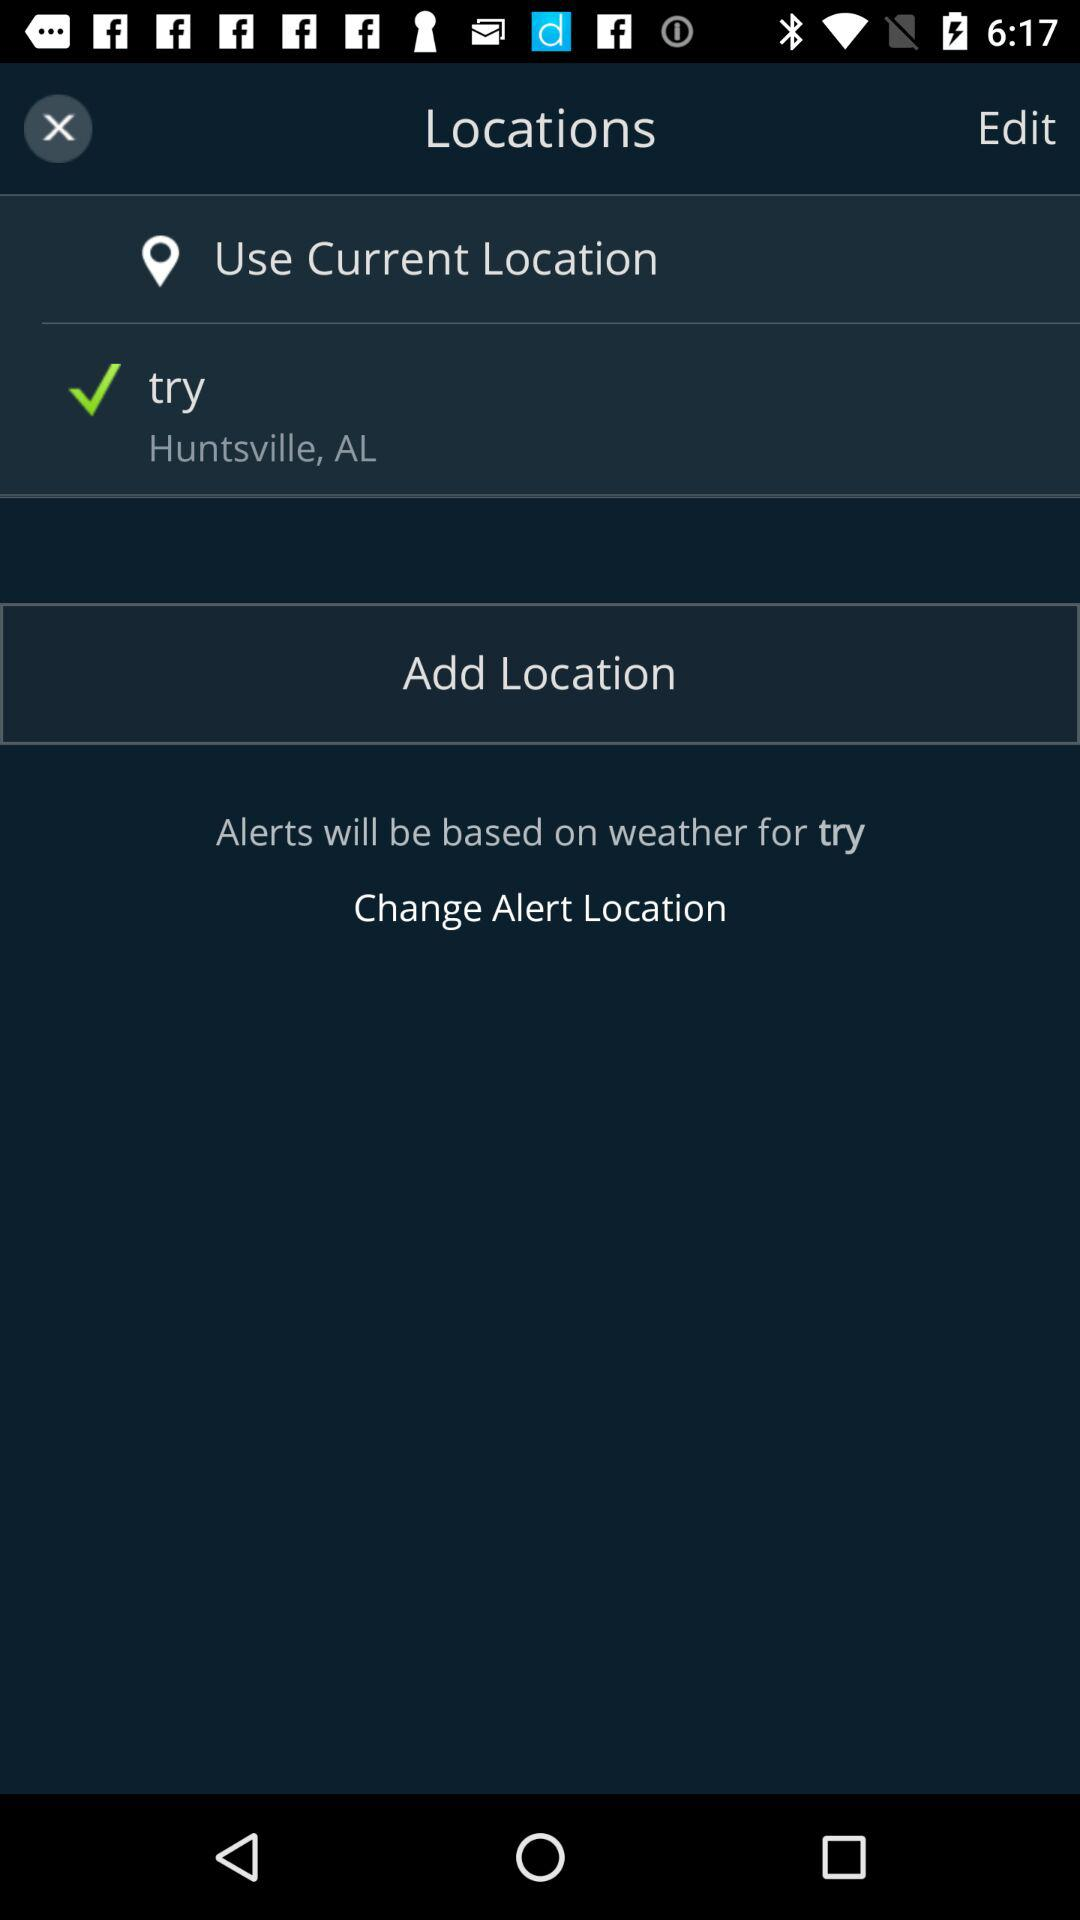What is the mentioned location? The mentioned location is Huntsville, AL. 